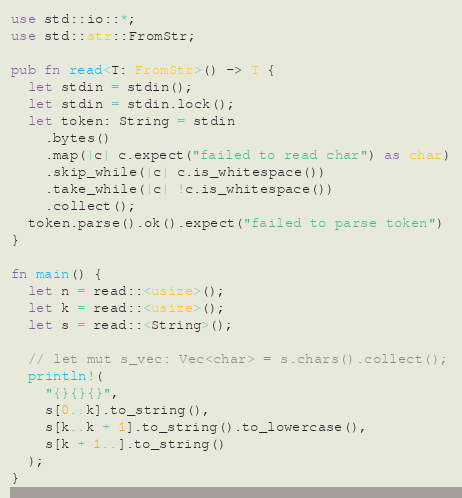Convert code to text. <code><loc_0><loc_0><loc_500><loc_500><_Rust_>use std::io::*;
use std::str::FromStr;

pub fn read<T: FromStr>() -> T {
  let stdin = stdin();
  let stdin = stdin.lock();
  let token: String = stdin
    .bytes()
    .map(|c| c.expect("failed to read char") as char)
    .skip_while(|c| c.is_whitespace())
    .take_while(|c| !c.is_whitespace())
    .collect();
  token.parse().ok().expect("failed to parse token")
}

fn main() {
  let n = read::<usize>();
  let k = read::<usize>();
  let s = read::<String>();

  // let mut s_vec: Vec<char> = s.chars().collect();
  println!(
    "{}{}{}",
    s[0..k].to_string(),
    s[k..k + 1].to_string().to_lowercase(),
    s[k + 1..].to_string()
  );
}
</code> 